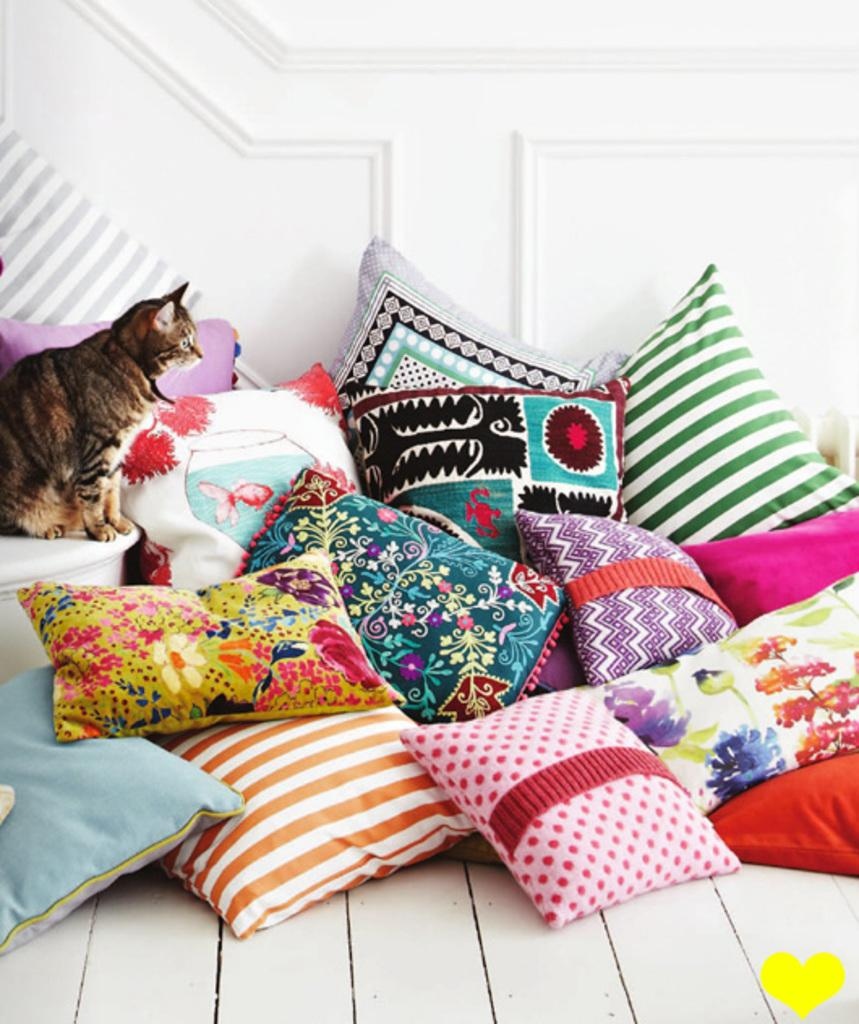What type of soft furnishings can be seen in the image? There are pillows in the image. What type of structure is visible in the image? There is a wall in the image. What type of animal is present in the image? There is a cat in the image. What type of surface is visible in the image? There is a floor in the image. What can be found at the bottom of the image? There is a logo at the bottom of the image. What type of pipe is visible in the image? There is no pipe present in the image. What word is written on the wall in the image? There is no word written on the wall in the image. 